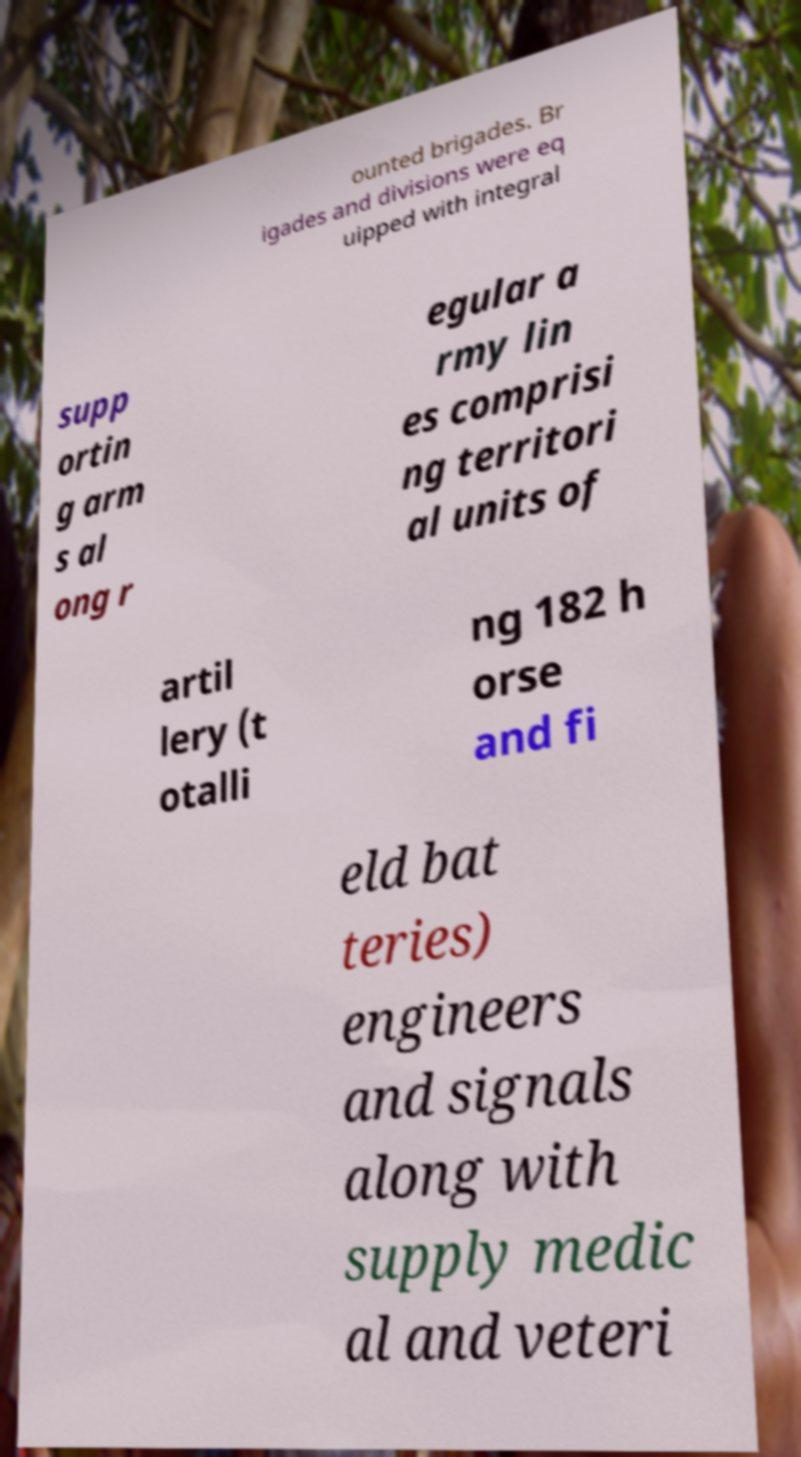There's text embedded in this image that I need extracted. Can you transcribe it verbatim? ounted brigades. Br igades and divisions were eq uipped with integral supp ortin g arm s al ong r egular a rmy lin es comprisi ng territori al units of artil lery (t otalli ng 182 h orse and fi eld bat teries) engineers and signals along with supply medic al and veteri 